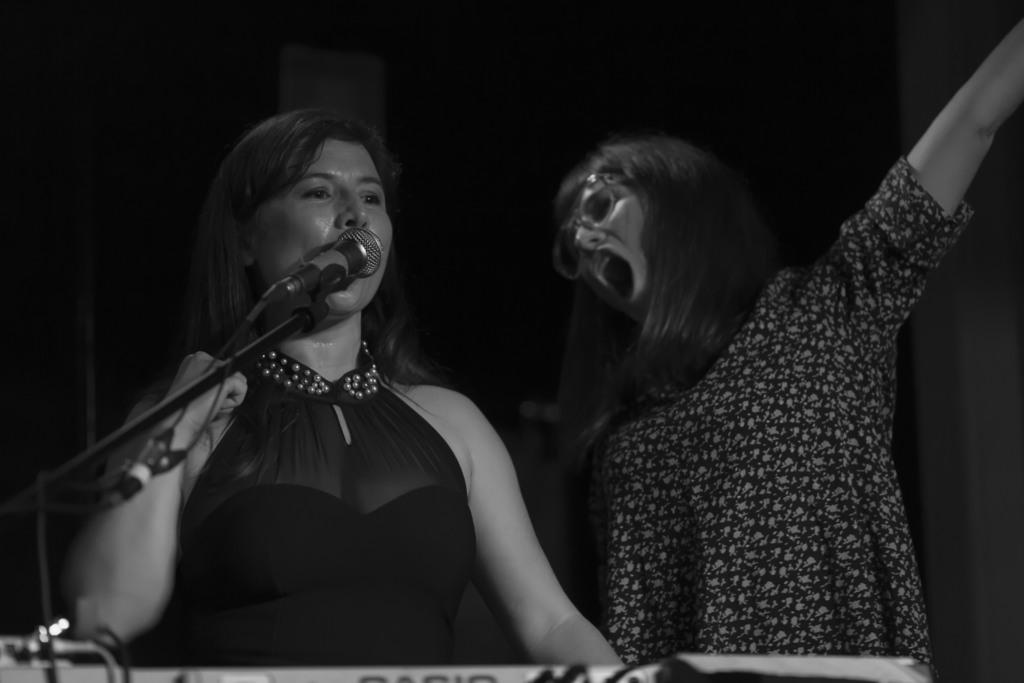What object is present in the image related to sound? There is a mic in the image. How many people are in the image? There are two persons in the image. What color are the dresses worn by the people in the image? The two persons are wearing black color dresses. Can you describe the lighting condition in the image? The image is a little dark. What type of riddle can be seen being solved by the two persons in the image? There is no riddle present in the image; it features a mic and two people wearing black dresses. What type of rake is being used by the person on the left side of the image? There is no rake present in the image; it only features a mic and two people wearing black dresses. 